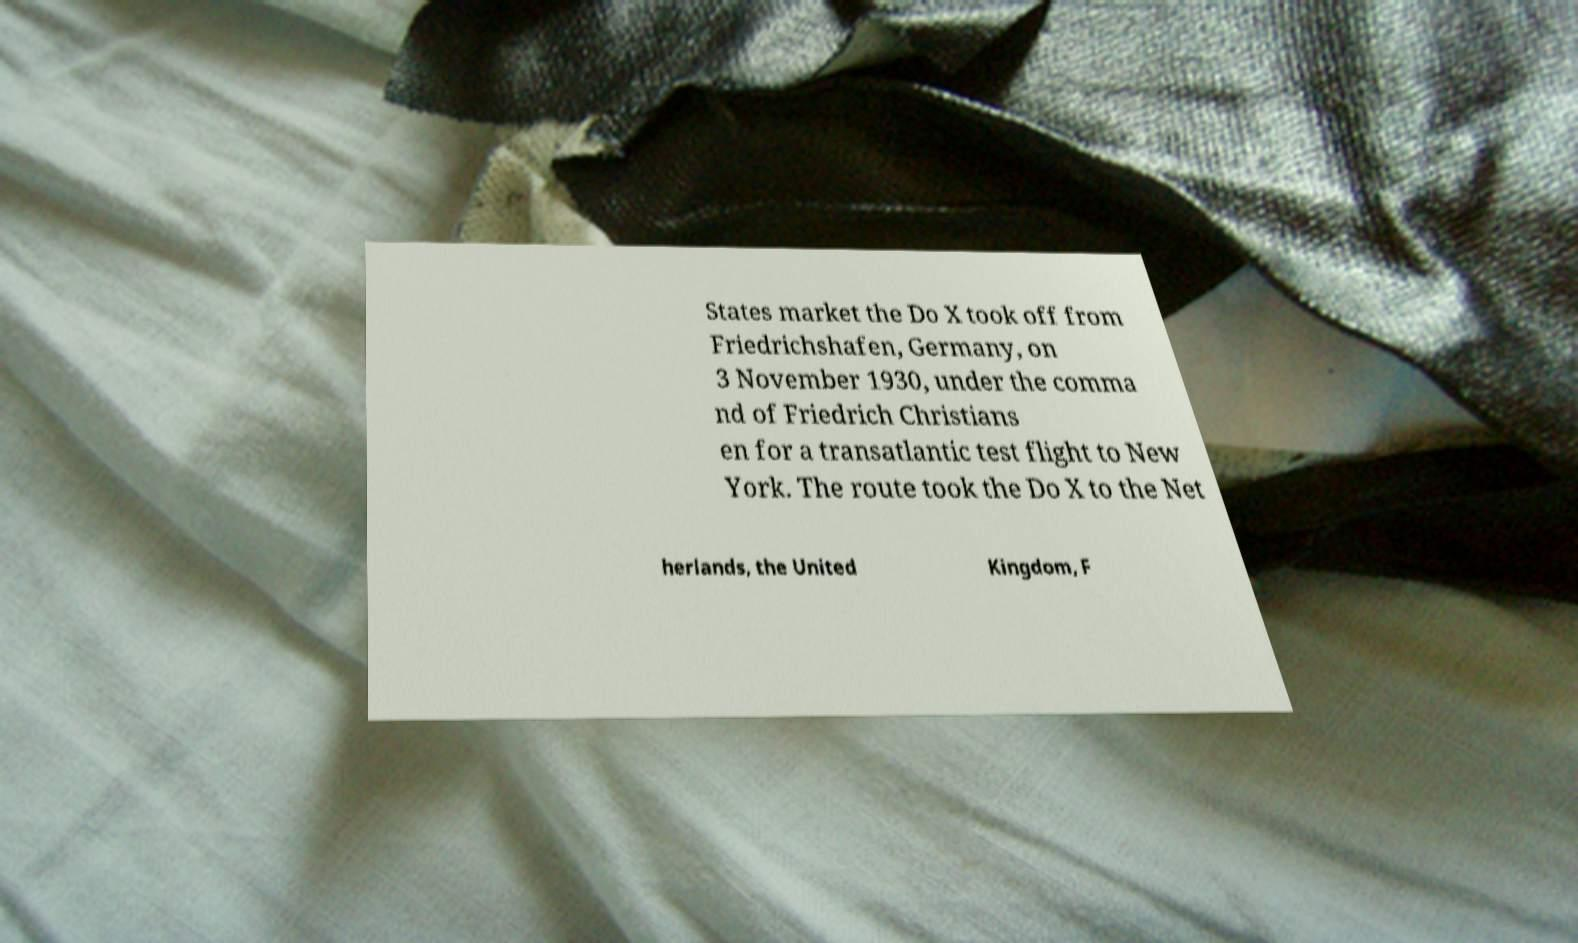For documentation purposes, I need the text within this image transcribed. Could you provide that? States market the Do X took off from Friedrichshafen, Germany, on 3 November 1930, under the comma nd of Friedrich Christians en for a transatlantic test flight to New York. The route took the Do X to the Net herlands, the United Kingdom, F 